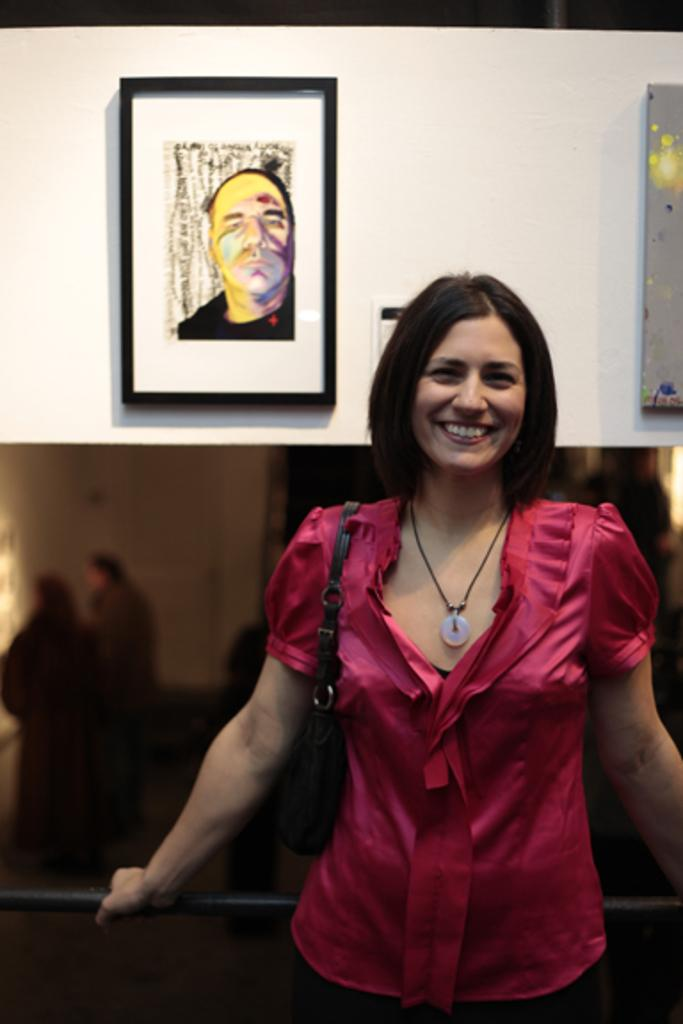What is the woman in the image doing? The woman is standing in the image. What is the woman holding in the image? The woman is holding an object. What can be seen on the wall in the image? Photo frames are attached to the wall in the image. What direction is the truck facing in the image? There is no truck present in the image. How many times does the object roll across the floor in the image? The object is being held by the woman, so it does not roll across the floor in the image. 